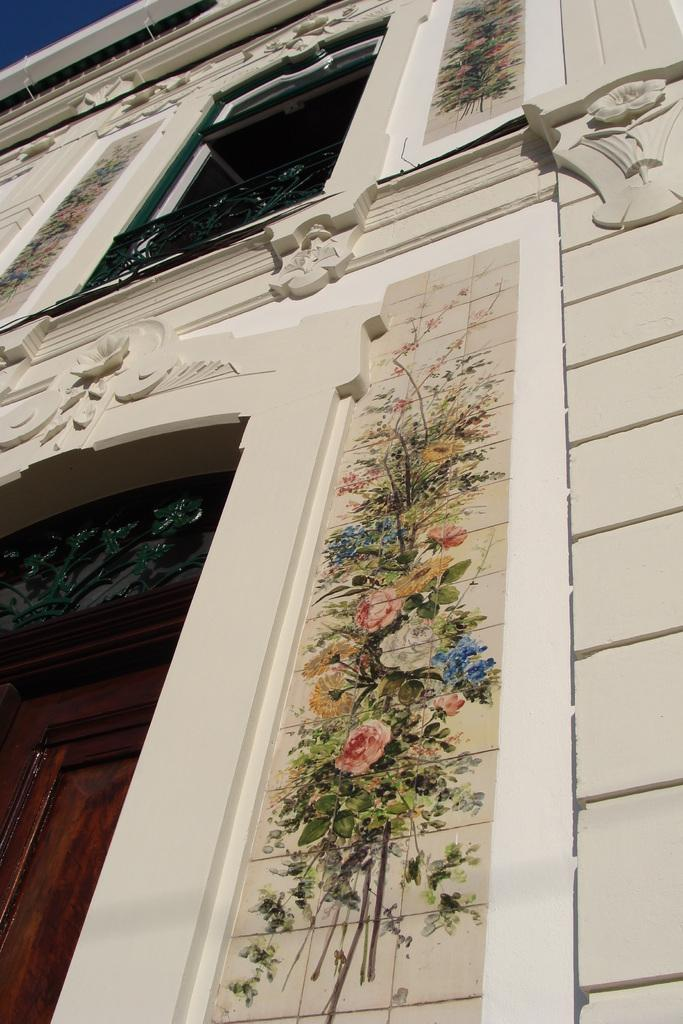What is the main structure visible in the image? There is a building in the image. Can you describe any additional features of the building? The building has a painting on it. What type of button can be seen on the painting of the building in the image? There is no button present on the painting of the building in the image. 